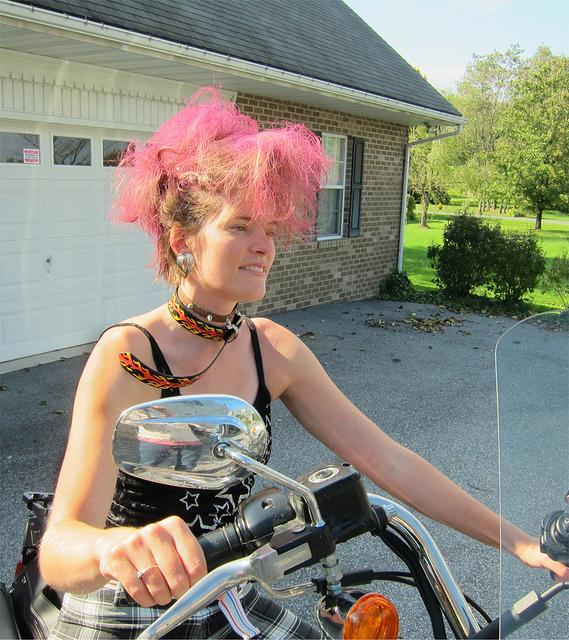Is the woman wearing jewelry?
Short answer required. Yes. What is the woman riding?
Quick response, please. Motorcycle. What color is the woman's hair?
Write a very short answer. Pink. 